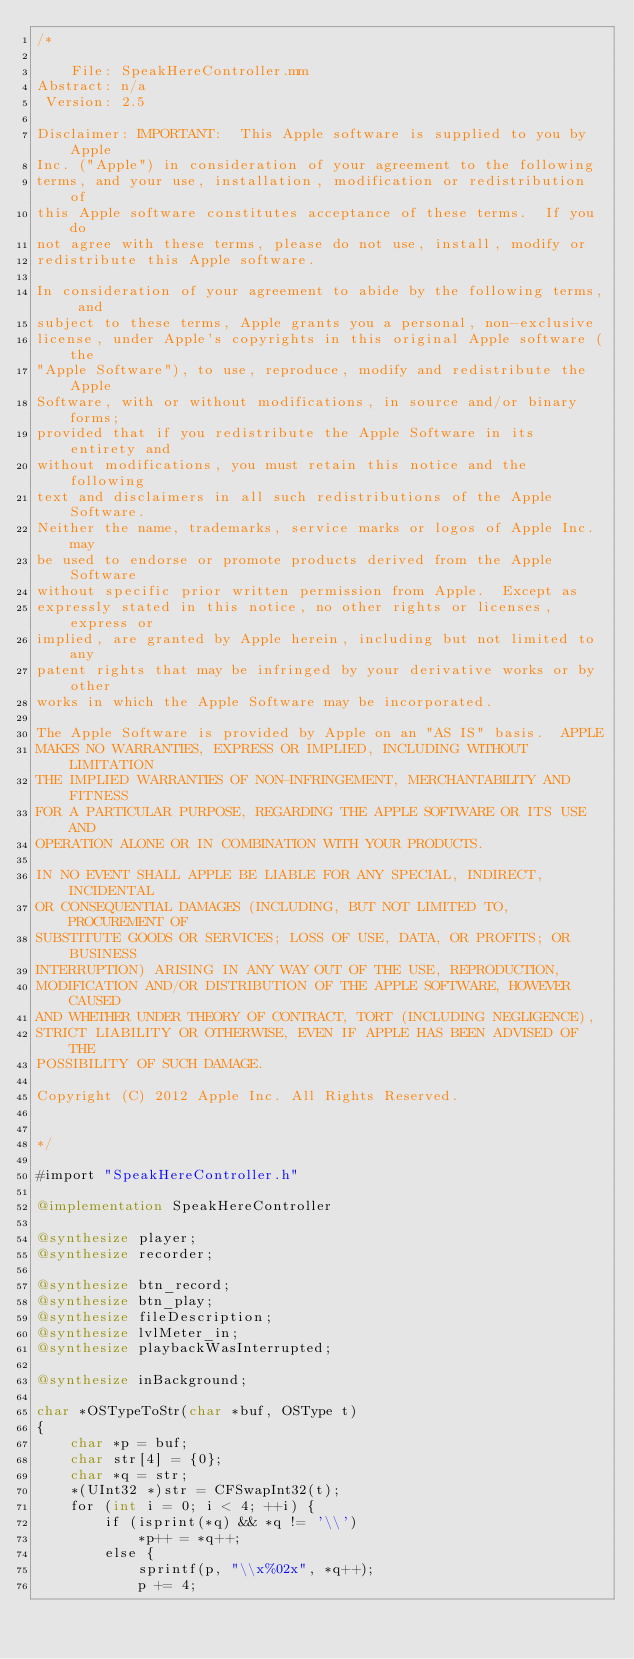Convert code to text. <code><loc_0><loc_0><loc_500><loc_500><_ObjectiveC_>/*

    File: SpeakHereController.mm
Abstract: n/a
 Version: 2.5

Disclaimer: IMPORTANT:  This Apple software is supplied to you by Apple
Inc. ("Apple") in consideration of your agreement to the following
terms, and your use, installation, modification or redistribution of
this Apple software constitutes acceptance of these terms.  If you do
not agree with these terms, please do not use, install, modify or
redistribute this Apple software.

In consideration of your agreement to abide by the following terms, and
subject to these terms, Apple grants you a personal, non-exclusive
license, under Apple's copyrights in this original Apple software (the
"Apple Software"), to use, reproduce, modify and redistribute the Apple
Software, with or without modifications, in source and/or binary forms;
provided that if you redistribute the Apple Software in its entirety and
without modifications, you must retain this notice and the following
text and disclaimers in all such redistributions of the Apple Software.
Neither the name, trademarks, service marks or logos of Apple Inc. may
be used to endorse or promote products derived from the Apple Software
without specific prior written permission from Apple.  Except as
expressly stated in this notice, no other rights or licenses, express or
implied, are granted by Apple herein, including but not limited to any
patent rights that may be infringed by your derivative works or by other
works in which the Apple Software may be incorporated.

The Apple Software is provided by Apple on an "AS IS" basis.  APPLE
MAKES NO WARRANTIES, EXPRESS OR IMPLIED, INCLUDING WITHOUT LIMITATION
THE IMPLIED WARRANTIES OF NON-INFRINGEMENT, MERCHANTABILITY AND FITNESS
FOR A PARTICULAR PURPOSE, REGARDING THE APPLE SOFTWARE OR ITS USE AND
OPERATION ALONE OR IN COMBINATION WITH YOUR PRODUCTS.

IN NO EVENT SHALL APPLE BE LIABLE FOR ANY SPECIAL, INDIRECT, INCIDENTAL
OR CONSEQUENTIAL DAMAGES (INCLUDING, BUT NOT LIMITED TO, PROCUREMENT OF
SUBSTITUTE GOODS OR SERVICES; LOSS OF USE, DATA, OR PROFITS; OR BUSINESS
INTERRUPTION) ARISING IN ANY WAY OUT OF THE USE, REPRODUCTION,
MODIFICATION AND/OR DISTRIBUTION OF THE APPLE SOFTWARE, HOWEVER CAUSED
AND WHETHER UNDER THEORY OF CONTRACT, TORT (INCLUDING NEGLIGENCE),
STRICT LIABILITY OR OTHERWISE, EVEN IF APPLE HAS BEEN ADVISED OF THE
POSSIBILITY OF SUCH DAMAGE.

Copyright (C) 2012 Apple Inc. All Rights Reserved.


*/

#import "SpeakHereController.h"

@implementation SpeakHereController

@synthesize player;
@synthesize recorder;

@synthesize btn_record;
@synthesize btn_play;
@synthesize fileDescription;
@synthesize lvlMeter_in;
@synthesize playbackWasInterrupted;

@synthesize inBackground;

char *OSTypeToStr(char *buf, OSType t)
{
	char *p = buf;
	char str[4] = {0};
    char *q = str;
	*(UInt32 *)str = CFSwapInt32(t);
	for (int i = 0; i < 4; ++i) {
		if (isprint(*q) && *q != '\\')
			*p++ = *q++;
		else {
			sprintf(p, "\\x%02x", *q++);
			p += 4;</code> 